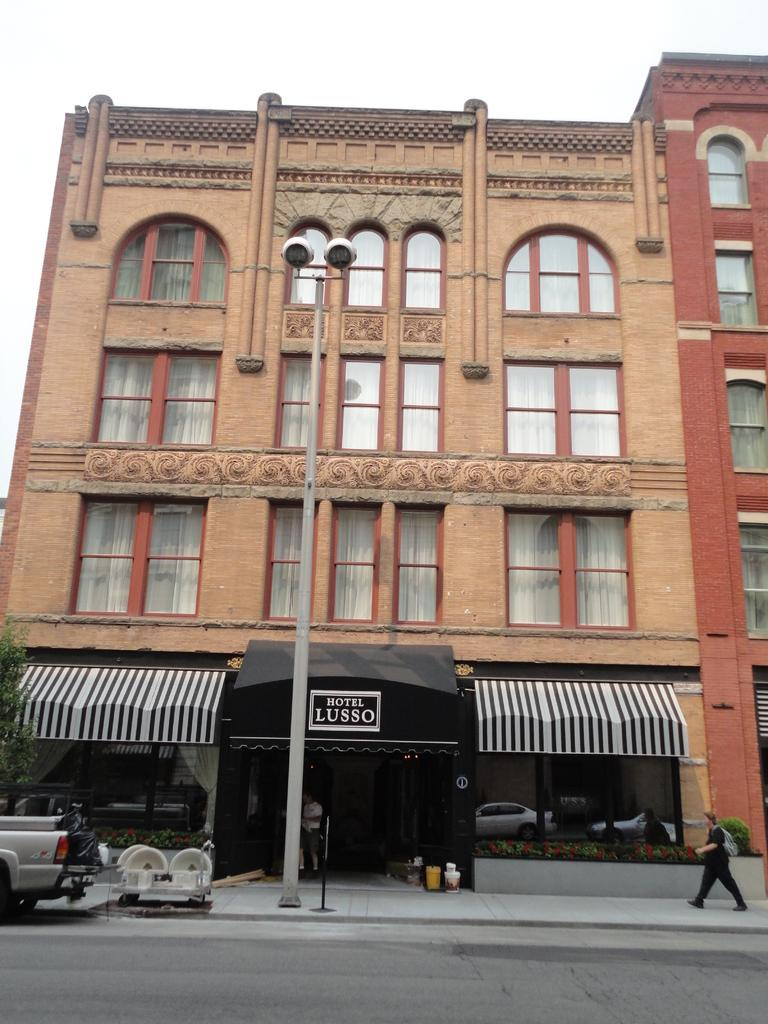What type of structure is present in the image? There is a building in the image. What feature can be seen on the building? The building has windows. What object is present in the image besides the building? There is a pole, a person walking, a car, and the sky is visible at the top of the image. Who is the creator of the sock that can be seen in the image? There is no sock present in the image, so it is not possible to determine who its creator might be. 